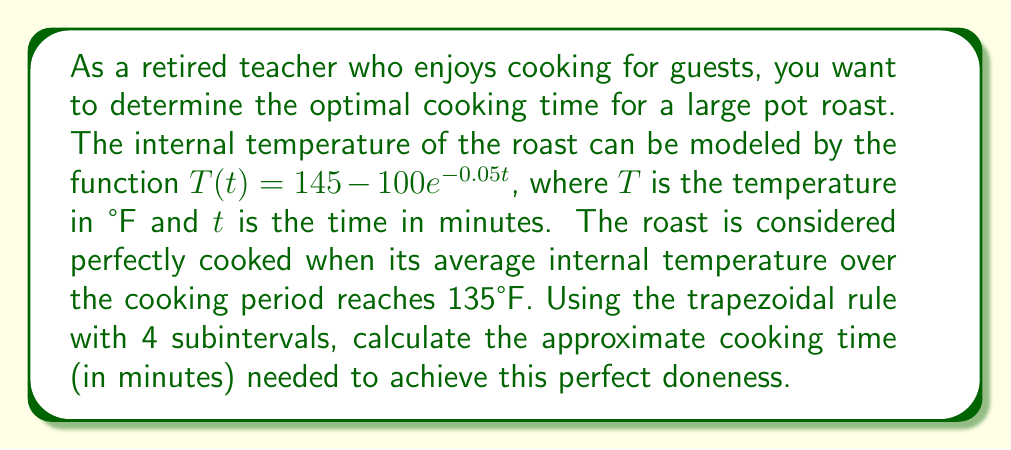Teach me how to tackle this problem. To solve this problem, we need to use numerical integration to find the average temperature over time and then determine when this average reaches 135°F. Let's break it down step-by-step:

1) The average temperature over time $[0, t]$ is given by:

   $$\frac{1}{t}\int_0^t T(x) dx = \frac{1}{t}\int_0^t (145 - 100e^{-0.05x}) dx = 135$$

2) We need to find $t$ that satisfies this equation. We can rewrite it as:

   $$\int_0^t (145 - 100e^{-0.05x}) dx = 135t$$

3) Let's use the trapezoidal rule with 4 subintervals to approximate the left side of the equation. We'll try different values of $t$ until we find one that satisfies the equation.

4) The trapezoidal rule formula with 4 subintervals is:

   $$\int_0^t f(x) dx \approx \frac{t}{8}[f(0) + 2f(\frac{t}{4}) + 2f(\frac{t}{2}) + 2f(\frac{3t}{4}) + f(t)]$$

5) Let's try $t = 80$ minutes:

   $$\begin{align*}
   f(0) &= 145 - 100 = 45 \\
   f(20) &= 145 - 100e^{-1} \approx 108.21 \\
   f(40) &= 145 - 100e^{-2} \approx 132.77 \\
   f(60) &= 145 - 100e^{-3} \approx 140.76 \\
   f(80) &= 145 - 100e^{-4} \approx 143.27
   \end{align*}$$

6) Applying the trapezoidal rule:

   $$\frac{80}{8}[45 + 2(108.21) + 2(132.77) + 2(140.76) + 143.27] \approx 10,802.8$$

7) Check if this equals $135t = 135 * 80 = 10,800$

   The approximation 10,802.8 is very close to 10,800, so 80 minutes is a good approximation for the optimal cooking time.
Answer: The approximate optimal cooking time for the pot roast is 80 minutes. 